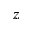Convert formula to latex. <formula><loc_0><loc_0><loc_500><loc_500>z</formula> 